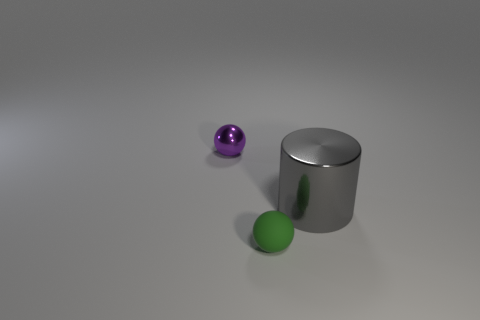Add 3 tiny objects. How many objects exist? 6 Subtract all cylinders. How many objects are left? 2 Add 1 small green rubber objects. How many small green rubber objects are left? 2 Add 2 blue matte objects. How many blue matte objects exist? 2 Subtract 0 yellow spheres. How many objects are left? 3 Subtract all small purple balls. Subtract all small spheres. How many objects are left? 0 